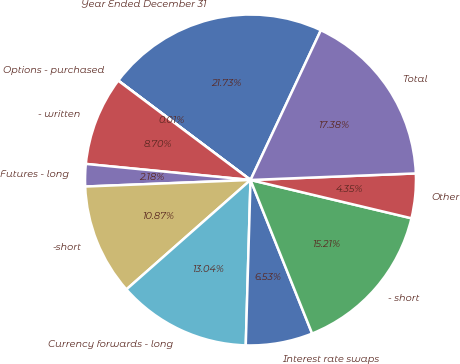Convert chart. <chart><loc_0><loc_0><loc_500><loc_500><pie_chart><fcel>Year Ended December 31<fcel>Options - purchased<fcel>- written<fcel>Futures - long<fcel>-short<fcel>Currency forwards - long<fcel>Interest rate swaps<fcel>- short<fcel>Other<fcel>Total<nl><fcel>21.73%<fcel>0.01%<fcel>8.7%<fcel>2.18%<fcel>10.87%<fcel>13.04%<fcel>6.53%<fcel>15.21%<fcel>4.35%<fcel>17.38%<nl></chart> 